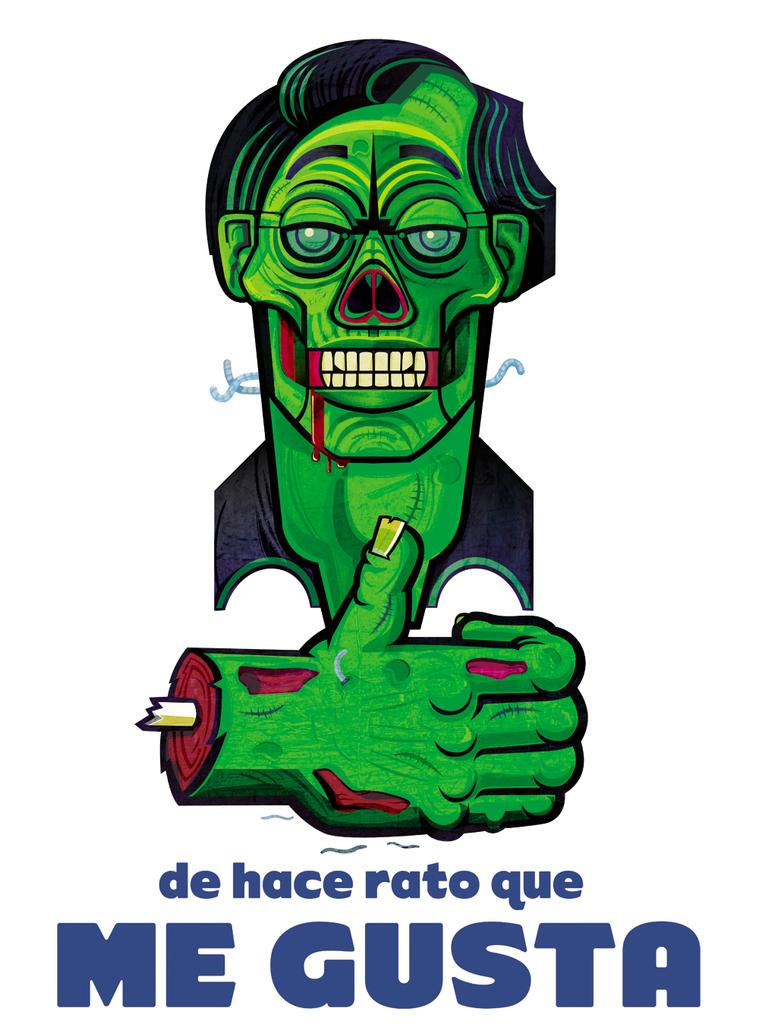<image>
Render a clear and concise summary of the photo. A picture of Frankenstein thatr reads Me Gusta underneath. 